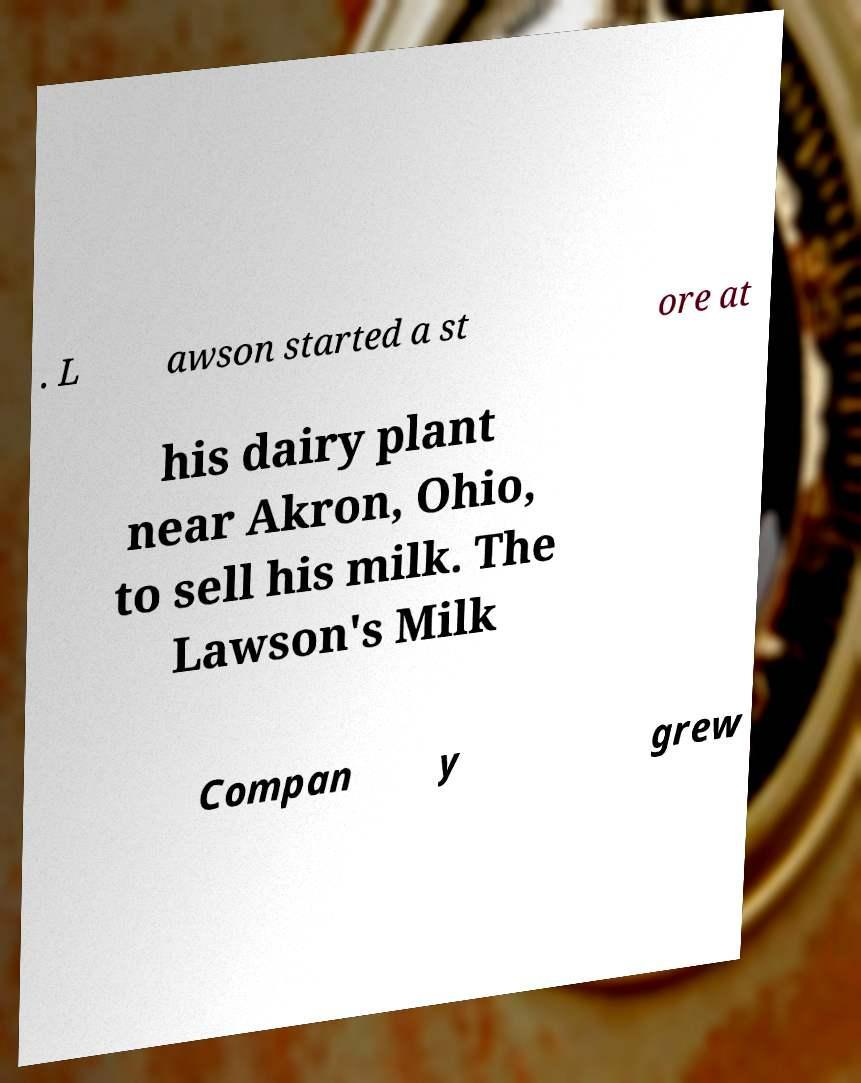Can you read and provide the text displayed in the image?This photo seems to have some interesting text. Can you extract and type it out for me? . L awson started a st ore at his dairy plant near Akron, Ohio, to sell his milk. The Lawson's Milk Compan y grew 